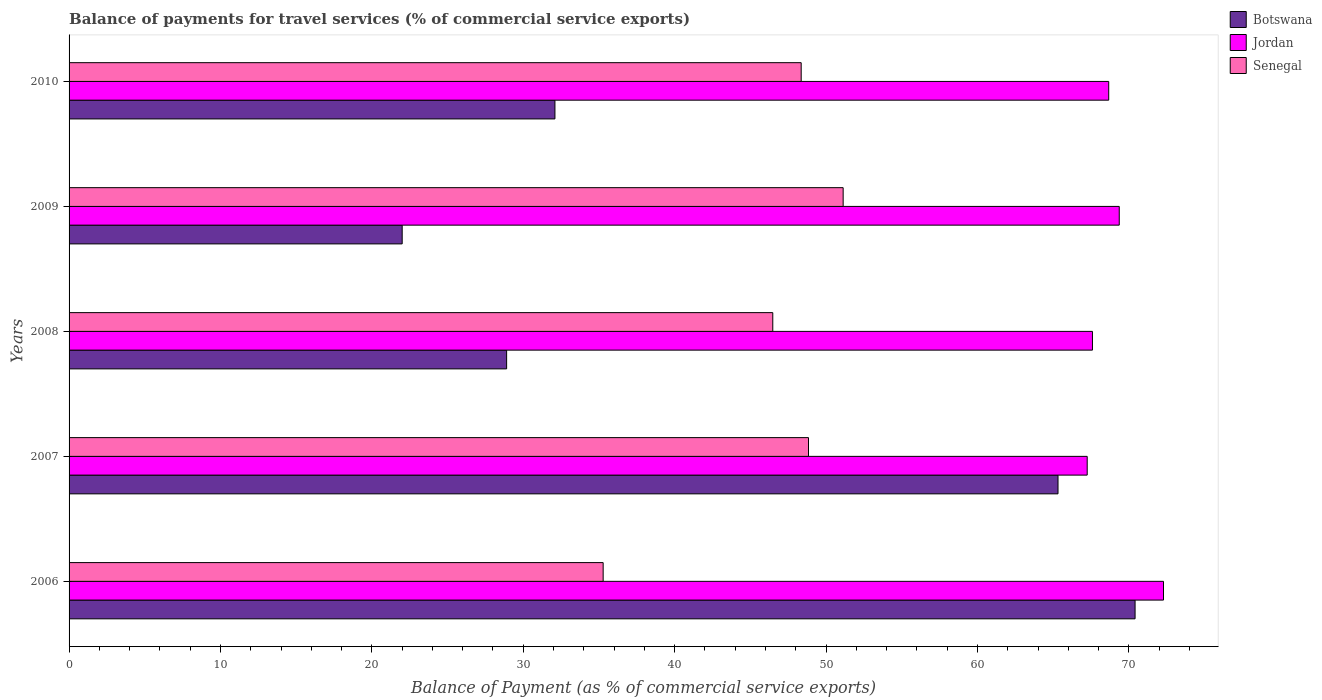How many groups of bars are there?
Make the answer very short. 5. Are the number of bars per tick equal to the number of legend labels?
Offer a very short reply. Yes. Are the number of bars on each tick of the Y-axis equal?
Ensure brevity in your answer.  Yes. What is the label of the 5th group of bars from the top?
Offer a terse response. 2006. In how many cases, is the number of bars for a given year not equal to the number of legend labels?
Offer a terse response. 0. What is the balance of payments for travel services in Botswana in 2006?
Give a very brief answer. 70.41. Across all years, what is the maximum balance of payments for travel services in Senegal?
Offer a terse response. 51.13. Across all years, what is the minimum balance of payments for travel services in Senegal?
Ensure brevity in your answer.  35.28. What is the total balance of payments for travel services in Senegal in the graph?
Offer a very short reply. 230.08. What is the difference between the balance of payments for travel services in Senegal in 2006 and that in 2007?
Make the answer very short. -13.56. What is the difference between the balance of payments for travel services in Botswana in 2006 and the balance of payments for travel services in Senegal in 2007?
Your answer should be compact. 21.57. What is the average balance of payments for travel services in Botswana per year?
Keep it short and to the point. 43.75. In the year 2008, what is the difference between the balance of payments for travel services in Botswana and balance of payments for travel services in Jordan?
Make the answer very short. -38.69. What is the ratio of the balance of payments for travel services in Senegal in 2006 to that in 2009?
Give a very brief answer. 0.69. Is the difference between the balance of payments for travel services in Botswana in 2006 and 2008 greater than the difference between the balance of payments for travel services in Jordan in 2006 and 2008?
Provide a succinct answer. Yes. What is the difference between the highest and the second highest balance of payments for travel services in Jordan?
Provide a succinct answer. 2.92. What is the difference between the highest and the lowest balance of payments for travel services in Botswana?
Keep it short and to the point. 48.41. What does the 1st bar from the top in 2009 represents?
Provide a succinct answer. Senegal. What does the 3rd bar from the bottom in 2009 represents?
Provide a succinct answer. Senegal. How many years are there in the graph?
Keep it short and to the point. 5. Are the values on the major ticks of X-axis written in scientific E-notation?
Your answer should be very brief. No. Does the graph contain any zero values?
Offer a terse response. No. Where does the legend appear in the graph?
Provide a short and direct response. Top right. What is the title of the graph?
Provide a succinct answer. Balance of payments for travel services (% of commercial service exports). Does "Least developed countries" appear as one of the legend labels in the graph?
Offer a very short reply. No. What is the label or title of the X-axis?
Make the answer very short. Balance of Payment (as % of commercial service exports). What is the Balance of Payment (as % of commercial service exports) in Botswana in 2006?
Keep it short and to the point. 70.41. What is the Balance of Payment (as % of commercial service exports) of Jordan in 2006?
Your answer should be compact. 72.29. What is the Balance of Payment (as % of commercial service exports) of Senegal in 2006?
Your response must be concise. 35.28. What is the Balance of Payment (as % of commercial service exports) in Botswana in 2007?
Your answer should be compact. 65.32. What is the Balance of Payment (as % of commercial service exports) of Jordan in 2007?
Provide a short and direct response. 67.25. What is the Balance of Payment (as % of commercial service exports) of Senegal in 2007?
Your answer should be very brief. 48.84. What is the Balance of Payment (as % of commercial service exports) of Botswana in 2008?
Ensure brevity in your answer.  28.9. What is the Balance of Payment (as % of commercial service exports) of Jordan in 2008?
Ensure brevity in your answer.  67.6. What is the Balance of Payment (as % of commercial service exports) of Senegal in 2008?
Your answer should be very brief. 46.48. What is the Balance of Payment (as % of commercial service exports) of Botswana in 2009?
Your answer should be very brief. 22. What is the Balance of Payment (as % of commercial service exports) in Jordan in 2009?
Keep it short and to the point. 69.37. What is the Balance of Payment (as % of commercial service exports) of Senegal in 2009?
Give a very brief answer. 51.13. What is the Balance of Payment (as % of commercial service exports) of Botswana in 2010?
Offer a very short reply. 32.09. What is the Balance of Payment (as % of commercial service exports) of Jordan in 2010?
Provide a succinct answer. 68.67. What is the Balance of Payment (as % of commercial service exports) of Senegal in 2010?
Offer a terse response. 48.36. Across all years, what is the maximum Balance of Payment (as % of commercial service exports) of Botswana?
Provide a succinct answer. 70.41. Across all years, what is the maximum Balance of Payment (as % of commercial service exports) of Jordan?
Give a very brief answer. 72.29. Across all years, what is the maximum Balance of Payment (as % of commercial service exports) in Senegal?
Your response must be concise. 51.13. Across all years, what is the minimum Balance of Payment (as % of commercial service exports) in Botswana?
Ensure brevity in your answer.  22. Across all years, what is the minimum Balance of Payment (as % of commercial service exports) in Jordan?
Provide a succinct answer. 67.25. Across all years, what is the minimum Balance of Payment (as % of commercial service exports) of Senegal?
Offer a very short reply. 35.28. What is the total Balance of Payment (as % of commercial service exports) of Botswana in the graph?
Offer a very short reply. 218.73. What is the total Balance of Payment (as % of commercial service exports) in Jordan in the graph?
Make the answer very short. 345.17. What is the total Balance of Payment (as % of commercial service exports) of Senegal in the graph?
Make the answer very short. 230.08. What is the difference between the Balance of Payment (as % of commercial service exports) of Botswana in 2006 and that in 2007?
Provide a succinct answer. 5.09. What is the difference between the Balance of Payment (as % of commercial service exports) of Jordan in 2006 and that in 2007?
Keep it short and to the point. 5.04. What is the difference between the Balance of Payment (as % of commercial service exports) of Senegal in 2006 and that in 2007?
Provide a short and direct response. -13.56. What is the difference between the Balance of Payment (as % of commercial service exports) of Botswana in 2006 and that in 2008?
Your answer should be compact. 41.51. What is the difference between the Balance of Payment (as % of commercial service exports) of Jordan in 2006 and that in 2008?
Offer a very short reply. 4.69. What is the difference between the Balance of Payment (as % of commercial service exports) in Senegal in 2006 and that in 2008?
Offer a terse response. -11.2. What is the difference between the Balance of Payment (as % of commercial service exports) of Botswana in 2006 and that in 2009?
Your answer should be very brief. 48.41. What is the difference between the Balance of Payment (as % of commercial service exports) of Jordan in 2006 and that in 2009?
Ensure brevity in your answer.  2.92. What is the difference between the Balance of Payment (as % of commercial service exports) of Senegal in 2006 and that in 2009?
Offer a very short reply. -15.85. What is the difference between the Balance of Payment (as % of commercial service exports) in Botswana in 2006 and that in 2010?
Make the answer very short. 38.32. What is the difference between the Balance of Payment (as % of commercial service exports) of Jordan in 2006 and that in 2010?
Your response must be concise. 3.62. What is the difference between the Balance of Payment (as % of commercial service exports) of Senegal in 2006 and that in 2010?
Offer a terse response. -13.08. What is the difference between the Balance of Payment (as % of commercial service exports) of Botswana in 2007 and that in 2008?
Your answer should be very brief. 36.42. What is the difference between the Balance of Payment (as % of commercial service exports) in Jordan in 2007 and that in 2008?
Give a very brief answer. -0.35. What is the difference between the Balance of Payment (as % of commercial service exports) of Senegal in 2007 and that in 2008?
Ensure brevity in your answer.  2.36. What is the difference between the Balance of Payment (as % of commercial service exports) in Botswana in 2007 and that in 2009?
Make the answer very short. 43.32. What is the difference between the Balance of Payment (as % of commercial service exports) of Jordan in 2007 and that in 2009?
Your answer should be very brief. -2.12. What is the difference between the Balance of Payment (as % of commercial service exports) in Senegal in 2007 and that in 2009?
Your response must be concise. -2.29. What is the difference between the Balance of Payment (as % of commercial service exports) in Botswana in 2007 and that in 2010?
Your response must be concise. 33.23. What is the difference between the Balance of Payment (as % of commercial service exports) of Jordan in 2007 and that in 2010?
Make the answer very short. -1.42. What is the difference between the Balance of Payment (as % of commercial service exports) in Senegal in 2007 and that in 2010?
Ensure brevity in your answer.  0.48. What is the difference between the Balance of Payment (as % of commercial service exports) of Botswana in 2008 and that in 2009?
Make the answer very short. 6.9. What is the difference between the Balance of Payment (as % of commercial service exports) in Jordan in 2008 and that in 2009?
Keep it short and to the point. -1.77. What is the difference between the Balance of Payment (as % of commercial service exports) of Senegal in 2008 and that in 2009?
Keep it short and to the point. -4.65. What is the difference between the Balance of Payment (as % of commercial service exports) in Botswana in 2008 and that in 2010?
Provide a short and direct response. -3.19. What is the difference between the Balance of Payment (as % of commercial service exports) of Jordan in 2008 and that in 2010?
Offer a terse response. -1.07. What is the difference between the Balance of Payment (as % of commercial service exports) in Senegal in 2008 and that in 2010?
Ensure brevity in your answer.  -1.88. What is the difference between the Balance of Payment (as % of commercial service exports) in Botswana in 2009 and that in 2010?
Keep it short and to the point. -10.09. What is the difference between the Balance of Payment (as % of commercial service exports) in Jordan in 2009 and that in 2010?
Keep it short and to the point. 0.7. What is the difference between the Balance of Payment (as % of commercial service exports) in Senegal in 2009 and that in 2010?
Provide a succinct answer. 2.77. What is the difference between the Balance of Payment (as % of commercial service exports) in Botswana in 2006 and the Balance of Payment (as % of commercial service exports) in Jordan in 2007?
Your answer should be compact. 3.16. What is the difference between the Balance of Payment (as % of commercial service exports) in Botswana in 2006 and the Balance of Payment (as % of commercial service exports) in Senegal in 2007?
Make the answer very short. 21.57. What is the difference between the Balance of Payment (as % of commercial service exports) of Jordan in 2006 and the Balance of Payment (as % of commercial service exports) of Senegal in 2007?
Your answer should be very brief. 23.45. What is the difference between the Balance of Payment (as % of commercial service exports) of Botswana in 2006 and the Balance of Payment (as % of commercial service exports) of Jordan in 2008?
Give a very brief answer. 2.82. What is the difference between the Balance of Payment (as % of commercial service exports) of Botswana in 2006 and the Balance of Payment (as % of commercial service exports) of Senegal in 2008?
Make the answer very short. 23.93. What is the difference between the Balance of Payment (as % of commercial service exports) of Jordan in 2006 and the Balance of Payment (as % of commercial service exports) of Senegal in 2008?
Ensure brevity in your answer.  25.81. What is the difference between the Balance of Payment (as % of commercial service exports) of Botswana in 2006 and the Balance of Payment (as % of commercial service exports) of Jordan in 2009?
Your response must be concise. 1.05. What is the difference between the Balance of Payment (as % of commercial service exports) in Botswana in 2006 and the Balance of Payment (as % of commercial service exports) in Senegal in 2009?
Make the answer very short. 19.28. What is the difference between the Balance of Payment (as % of commercial service exports) of Jordan in 2006 and the Balance of Payment (as % of commercial service exports) of Senegal in 2009?
Your answer should be compact. 21.16. What is the difference between the Balance of Payment (as % of commercial service exports) of Botswana in 2006 and the Balance of Payment (as % of commercial service exports) of Jordan in 2010?
Give a very brief answer. 1.74. What is the difference between the Balance of Payment (as % of commercial service exports) in Botswana in 2006 and the Balance of Payment (as % of commercial service exports) in Senegal in 2010?
Offer a terse response. 22.05. What is the difference between the Balance of Payment (as % of commercial service exports) of Jordan in 2006 and the Balance of Payment (as % of commercial service exports) of Senegal in 2010?
Give a very brief answer. 23.93. What is the difference between the Balance of Payment (as % of commercial service exports) in Botswana in 2007 and the Balance of Payment (as % of commercial service exports) in Jordan in 2008?
Offer a terse response. -2.28. What is the difference between the Balance of Payment (as % of commercial service exports) of Botswana in 2007 and the Balance of Payment (as % of commercial service exports) of Senegal in 2008?
Ensure brevity in your answer.  18.84. What is the difference between the Balance of Payment (as % of commercial service exports) of Jordan in 2007 and the Balance of Payment (as % of commercial service exports) of Senegal in 2008?
Your response must be concise. 20.77. What is the difference between the Balance of Payment (as % of commercial service exports) in Botswana in 2007 and the Balance of Payment (as % of commercial service exports) in Jordan in 2009?
Your answer should be very brief. -4.04. What is the difference between the Balance of Payment (as % of commercial service exports) in Botswana in 2007 and the Balance of Payment (as % of commercial service exports) in Senegal in 2009?
Provide a short and direct response. 14.19. What is the difference between the Balance of Payment (as % of commercial service exports) of Jordan in 2007 and the Balance of Payment (as % of commercial service exports) of Senegal in 2009?
Give a very brief answer. 16.12. What is the difference between the Balance of Payment (as % of commercial service exports) in Botswana in 2007 and the Balance of Payment (as % of commercial service exports) in Jordan in 2010?
Your response must be concise. -3.35. What is the difference between the Balance of Payment (as % of commercial service exports) in Botswana in 2007 and the Balance of Payment (as % of commercial service exports) in Senegal in 2010?
Ensure brevity in your answer.  16.96. What is the difference between the Balance of Payment (as % of commercial service exports) of Jordan in 2007 and the Balance of Payment (as % of commercial service exports) of Senegal in 2010?
Your answer should be compact. 18.89. What is the difference between the Balance of Payment (as % of commercial service exports) in Botswana in 2008 and the Balance of Payment (as % of commercial service exports) in Jordan in 2009?
Your response must be concise. -40.46. What is the difference between the Balance of Payment (as % of commercial service exports) in Botswana in 2008 and the Balance of Payment (as % of commercial service exports) in Senegal in 2009?
Your answer should be very brief. -22.23. What is the difference between the Balance of Payment (as % of commercial service exports) in Jordan in 2008 and the Balance of Payment (as % of commercial service exports) in Senegal in 2009?
Offer a very short reply. 16.47. What is the difference between the Balance of Payment (as % of commercial service exports) in Botswana in 2008 and the Balance of Payment (as % of commercial service exports) in Jordan in 2010?
Make the answer very short. -39.77. What is the difference between the Balance of Payment (as % of commercial service exports) in Botswana in 2008 and the Balance of Payment (as % of commercial service exports) in Senegal in 2010?
Make the answer very short. -19.46. What is the difference between the Balance of Payment (as % of commercial service exports) of Jordan in 2008 and the Balance of Payment (as % of commercial service exports) of Senegal in 2010?
Provide a short and direct response. 19.24. What is the difference between the Balance of Payment (as % of commercial service exports) of Botswana in 2009 and the Balance of Payment (as % of commercial service exports) of Jordan in 2010?
Give a very brief answer. -46.67. What is the difference between the Balance of Payment (as % of commercial service exports) in Botswana in 2009 and the Balance of Payment (as % of commercial service exports) in Senegal in 2010?
Your response must be concise. -26.35. What is the difference between the Balance of Payment (as % of commercial service exports) in Jordan in 2009 and the Balance of Payment (as % of commercial service exports) in Senegal in 2010?
Ensure brevity in your answer.  21.01. What is the average Balance of Payment (as % of commercial service exports) of Botswana per year?
Make the answer very short. 43.75. What is the average Balance of Payment (as % of commercial service exports) in Jordan per year?
Ensure brevity in your answer.  69.03. What is the average Balance of Payment (as % of commercial service exports) in Senegal per year?
Provide a short and direct response. 46.02. In the year 2006, what is the difference between the Balance of Payment (as % of commercial service exports) in Botswana and Balance of Payment (as % of commercial service exports) in Jordan?
Give a very brief answer. -1.88. In the year 2006, what is the difference between the Balance of Payment (as % of commercial service exports) of Botswana and Balance of Payment (as % of commercial service exports) of Senegal?
Offer a terse response. 35.13. In the year 2006, what is the difference between the Balance of Payment (as % of commercial service exports) in Jordan and Balance of Payment (as % of commercial service exports) in Senegal?
Make the answer very short. 37.01. In the year 2007, what is the difference between the Balance of Payment (as % of commercial service exports) in Botswana and Balance of Payment (as % of commercial service exports) in Jordan?
Your response must be concise. -1.93. In the year 2007, what is the difference between the Balance of Payment (as % of commercial service exports) in Botswana and Balance of Payment (as % of commercial service exports) in Senegal?
Provide a short and direct response. 16.48. In the year 2007, what is the difference between the Balance of Payment (as % of commercial service exports) of Jordan and Balance of Payment (as % of commercial service exports) of Senegal?
Provide a short and direct response. 18.41. In the year 2008, what is the difference between the Balance of Payment (as % of commercial service exports) of Botswana and Balance of Payment (as % of commercial service exports) of Jordan?
Provide a short and direct response. -38.69. In the year 2008, what is the difference between the Balance of Payment (as % of commercial service exports) in Botswana and Balance of Payment (as % of commercial service exports) in Senegal?
Ensure brevity in your answer.  -17.58. In the year 2008, what is the difference between the Balance of Payment (as % of commercial service exports) of Jordan and Balance of Payment (as % of commercial service exports) of Senegal?
Offer a terse response. 21.11. In the year 2009, what is the difference between the Balance of Payment (as % of commercial service exports) in Botswana and Balance of Payment (as % of commercial service exports) in Jordan?
Ensure brevity in your answer.  -47.36. In the year 2009, what is the difference between the Balance of Payment (as % of commercial service exports) in Botswana and Balance of Payment (as % of commercial service exports) in Senegal?
Your response must be concise. -29.13. In the year 2009, what is the difference between the Balance of Payment (as % of commercial service exports) in Jordan and Balance of Payment (as % of commercial service exports) in Senegal?
Offer a terse response. 18.24. In the year 2010, what is the difference between the Balance of Payment (as % of commercial service exports) in Botswana and Balance of Payment (as % of commercial service exports) in Jordan?
Your answer should be very brief. -36.58. In the year 2010, what is the difference between the Balance of Payment (as % of commercial service exports) of Botswana and Balance of Payment (as % of commercial service exports) of Senegal?
Your answer should be very brief. -16.27. In the year 2010, what is the difference between the Balance of Payment (as % of commercial service exports) of Jordan and Balance of Payment (as % of commercial service exports) of Senegal?
Make the answer very short. 20.31. What is the ratio of the Balance of Payment (as % of commercial service exports) of Botswana in 2006 to that in 2007?
Offer a terse response. 1.08. What is the ratio of the Balance of Payment (as % of commercial service exports) of Jordan in 2006 to that in 2007?
Provide a succinct answer. 1.07. What is the ratio of the Balance of Payment (as % of commercial service exports) in Senegal in 2006 to that in 2007?
Give a very brief answer. 0.72. What is the ratio of the Balance of Payment (as % of commercial service exports) of Botswana in 2006 to that in 2008?
Your response must be concise. 2.44. What is the ratio of the Balance of Payment (as % of commercial service exports) in Jordan in 2006 to that in 2008?
Offer a terse response. 1.07. What is the ratio of the Balance of Payment (as % of commercial service exports) of Senegal in 2006 to that in 2008?
Offer a terse response. 0.76. What is the ratio of the Balance of Payment (as % of commercial service exports) in Botswana in 2006 to that in 2009?
Offer a terse response. 3.2. What is the ratio of the Balance of Payment (as % of commercial service exports) of Jordan in 2006 to that in 2009?
Your answer should be compact. 1.04. What is the ratio of the Balance of Payment (as % of commercial service exports) of Senegal in 2006 to that in 2009?
Offer a terse response. 0.69. What is the ratio of the Balance of Payment (as % of commercial service exports) of Botswana in 2006 to that in 2010?
Make the answer very short. 2.19. What is the ratio of the Balance of Payment (as % of commercial service exports) of Jordan in 2006 to that in 2010?
Ensure brevity in your answer.  1.05. What is the ratio of the Balance of Payment (as % of commercial service exports) in Senegal in 2006 to that in 2010?
Keep it short and to the point. 0.73. What is the ratio of the Balance of Payment (as % of commercial service exports) of Botswana in 2007 to that in 2008?
Make the answer very short. 2.26. What is the ratio of the Balance of Payment (as % of commercial service exports) in Senegal in 2007 to that in 2008?
Offer a terse response. 1.05. What is the ratio of the Balance of Payment (as % of commercial service exports) in Botswana in 2007 to that in 2009?
Ensure brevity in your answer.  2.97. What is the ratio of the Balance of Payment (as % of commercial service exports) of Jordan in 2007 to that in 2009?
Keep it short and to the point. 0.97. What is the ratio of the Balance of Payment (as % of commercial service exports) in Senegal in 2007 to that in 2009?
Provide a succinct answer. 0.96. What is the ratio of the Balance of Payment (as % of commercial service exports) of Botswana in 2007 to that in 2010?
Provide a short and direct response. 2.04. What is the ratio of the Balance of Payment (as % of commercial service exports) of Jordan in 2007 to that in 2010?
Make the answer very short. 0.98. What is the ratio of the Balance of Payment (as % of commercial service exports) in Senegal in 2007 to that in 2010?
Offer a terse response. 1.01. What is the ratio of the Balance of Payment (as % of commercial service exports) of Botswana in 2008 to that in 2009?
Offer a terse response. 1.31. What is the ratio of the Balance of Payment (as % of commercial service exports) of Jordan in 2008 to that in 2009?
Offer a terse response. 0.97. What is the ratio of the Balance of Payment (as % of commercial service exports) in Senegal in 2008 to that in 2009?
Ensure brevity in your answer.  0.91. What is the ratio of the Balance of Payment (as % of commercial service exports) of Botswana in 2008 to that in 2010?
Your answer should be very brief. 0.9. What is the ratio of the Balance of Payment (as % of commercial service exports) of Jordan in 2008 to that in 2010?
Offer a very short reply. 0.98. What is the ratio of the Balance of Payment (as % of commercial service exports) in Senegal in 2008 to that in 2010?
Make the answer very short. 0.96. What is the ratio of the Balance of Payment (as % of commercial service exports) in Botswana in 2009 to that in 2010?
Give a very brief answer. 0.69. What is the ratio of the Balance of Payment (as % of commercial service exports) in Senegal in 2009 to that in 2010?
Your response must be concise. 1.06. What is the difference between the highest and the second highest Balance of Payment (as % of commercial service exports) of Botswana?
Make the answer very short. 5.09. What is the difference between the highest and the second highest Balance of Payment (as % of commercial service exports) in Jordan?
Provide a short and direct response. 2.92. What is the difference between the highest and the second highest Balance of Payment (as % of commercial service exports) of Senegal?
Keep it short and to the point. 2.29. What is the difference between the highest and the lowest Balance of Payment (as % of commercial service exports) in Botswana?
Your answer should be very brief. 48.41. What is the difference between the highest and the lowest Balance of Payment (as % of commercial service exports) of Jordan?
Your answer should be compact. 5.04. What is the difference between the highest and the lowest Balance of Payment (as % of commercial service exports) of Senegal?
Keep it short and to the point. 15.85. 